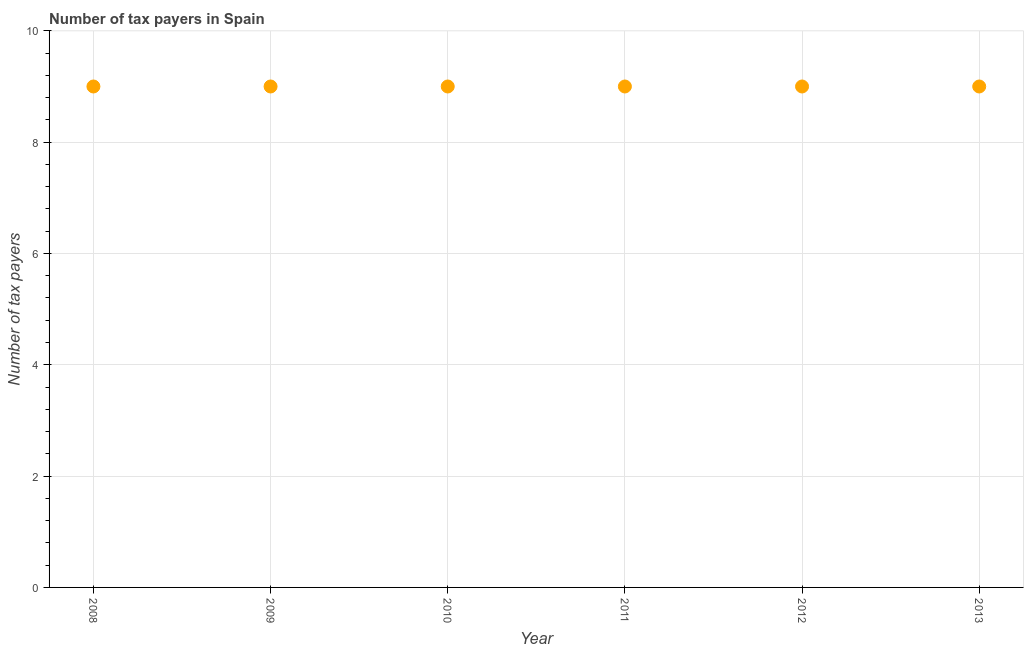What is the number of tax payers in 2009?
Your answer should be very brief. 9. Across all years, what is the maximum number of tax payers?
Provide a succinct answer. 9. Across all years, what is the minimum number of tax payers?
Offer a very short reply. 9. What is the sum of the number of tax payers?
Offer a terse response. 54. What is the difference between the number of tax payers in 2009 and 2010?
Ensure brevity in your answer.  0. What is the average number of tax payers per year?
Your response must be concise. 9. In how many years, is the number of tax payers greater than 4 ?
Your answer should be very brief. 6. Do a majority of the years between 2009 and 2013 (inclusive) have number of tax payers greater than 0.8 ?
Your response must be concise. Yes. What is the ratio of the number of tax payers in 2012 to that in 2013?
Provide a short and direct response. 1. Is the number of tax payers in 2009 less than that in 2013?
Provide a succinct answer. No. Is the difference between the number of tax payers in 2012 and 2013 greater than the difference between any two years?
Provide a short and direct response. Yes. What is the difference between the highest and the second highest number of tax payers?
Your answer should be very brief. 0. Is the sum of the number of tax payers in 2010 and 2011 greater than the maximum number of tax payers across all years?
Offer a very short reply. Yes. In how many years, is the number of tax payers greater than the average number of tax payers taken over all years?
Your response must be concise. 0. Does the number of tax payers monotonically increase over the years?
Ensure brevity in your answer.  No. How many dotlines are there?
Your answer should be compact. 1. How many years are there in the graph?
Offer a terse response. 6. Does the graph contain grids?
Your answer should be compact. Yes. What is the title of the graph?
Your response must be concise. Number of tax payers in Spain. What is the label or title of the Y-axis?
Make the answer very short. Number of tax payers. What is the Number of tax payers in 2012?
Ensure brevity in your answer.  9. What is the difference between the Number of tax payers in 2008 and 2009?
Make the answer very short. 0. What is the difference between the Number of tax payers in 2008 and 2010?
Your response must be concise. 0. What is the difference between the Number of tax payers in 2009 and 2011?
Give a very brief answer. 0. What is the difference between the Number of tax payers in 2010 and 2011?
Give a very brief answer. 0. What is the difference between the Number of tax payers in 2010 and 2012?
Your response must be concise. 0. What is the difference between the Number of tax payers in 2011 and 2013?
Make the answer very short. 0. What is the difference between the Number of tax payers in 2012 and 2013?
Offer a terse response. 0. What is the ratio of the Number of tax payers in 2008 to that in 2011?
Ensure brevity in your answer.  1. What is the ratio of the Number of tax payers in 2009 to that in 2010?
Provide a succinct answer. 1. What is the ratio of the Number of tax payers in 2009 to that in 2011?
Make the answer very short. 1. What is the ratio of the Number of tax payers in 2009 to that in 2013?
Offer a very short reply. 1. What is the ratio of the Number of tax payers in 2010 to that in 2012?
Provide a succinct answer. 1. What is the ratio of the Number of tax payers in 2011 to that in 2012?
Make the answer very short. 1. What is the ratio of the Number of tax payers in 2012 to that in 2013?
Your answer should be compact. 1. 